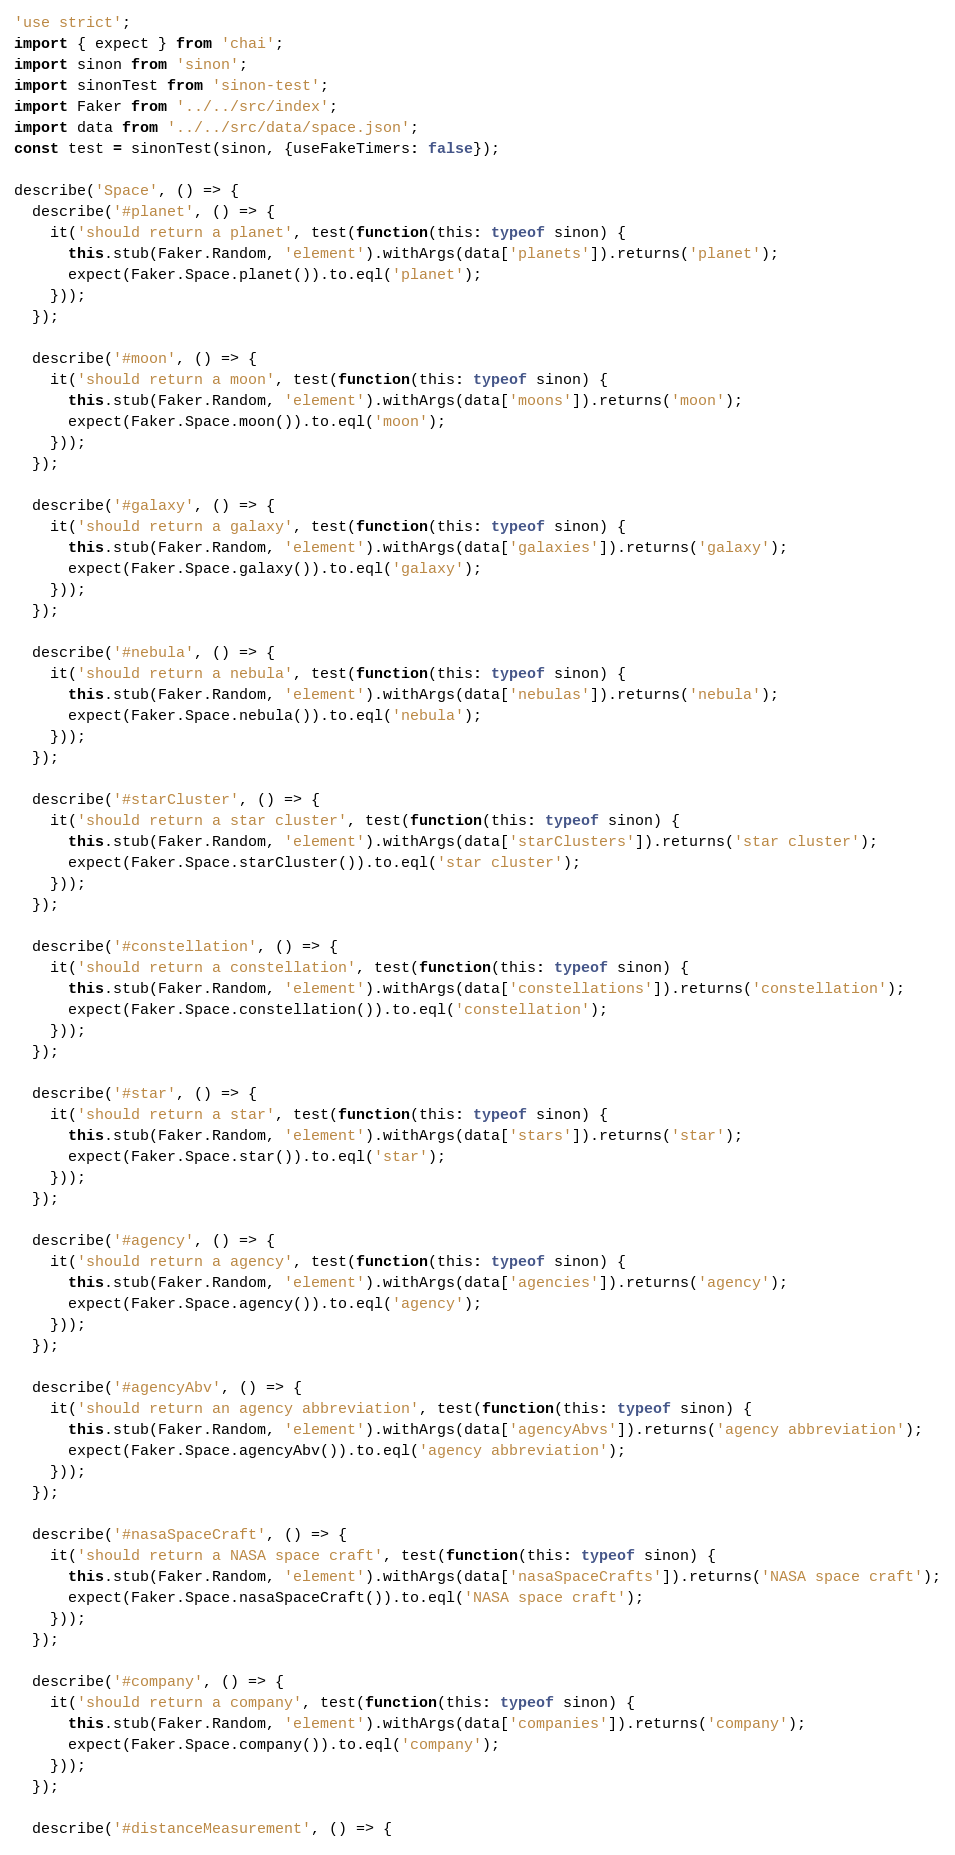<code> <loc_0><loc_0><loc_500><loc_500><_TypeScript_>'use strict';
import { expect } from 'chai';
import sinon from 'sinon';
import sinonTest from 'sinon-test';
import Faker from '../../src/index';
import data from '../../src/data/space.json';
const test = sinonTest(sinon, {useFakeTimers: false});

describe('Space', () => {
  describe('#planet', () => {
    it('should return a planet', test(function(this: typeof sinon) {
      this.stub(Faker.Random, 'element').withArgs(data['planets']).returns('planet');
      expect(Faker.Space.planet()).to.eql('planet');
    }));
  });

  describe('#moon', () => {
    it('should return a moon', test(function(this: typeof sinon) {
      this.stub(Faker.Random, 'element').withArgs(data['moons']).returns('moon');
      expect(Faker.Space.moon()).to.eql('moon');
    }));
  });

  describe('#galaxy', () => {
    it('should return a galaxy', test(function(this: typeof sinon) {
      this.stub(Faker.Random, 'element').withArgs(data['galaxies']).returns('galaxy');
      expect(Faker.Space.galaxy()).to.eql('galaxy');
    }));
  });

  describe('#nebula', () => {
    it('should return a nebula', test(function(this: typeof sinon) {
      this.stub(Faker.Random, 'element').withArgs(data['nebulas']).returns('nebula');
      expect(Faker.Space.nebula()).to.eql('nebula');
    }));
  });

  describe('#starCluster', () => {
    it('should return a star cluster', test(function(this: typeof sinon) {
      this.stub(Faker.Random, 'element').withArgs(data['starClusters']).returns('star cluster');
      expect(Faker.Space.starCluster()).to.eql('star cluster');
    }));
  });

  describe('#constellation', () => {
    it('should return a constellation', test(function(this: typeof sinon) {
      this.stub(Faker.Random, 'element').withArgs(data['constellations']).returns('constellation');
      expect(Faker.Space.constellation()).to.eql('constellation');
    }));
  });

  describe('#star', () => {
    it('should return a star', test(function(this: typeof sinon) {
      this.stub(Faker.Random, 'element').withArgs(data['stars']).returns('star');
      expect(Faker.Space.star()).to.eql('star');
    }));
  });

  describe('#agency', () => {
    it('should return a agency', test(function(this: typeof sinon) {
      this.stub(Faker.Random, 'element').withArgs(data['agencies']).returns('agency');
      expect(Faker.Space.agency()).to.eql('agency');
    }));
  });

  describe('#agencyAbv', () => {
    it('should return an agency abbreviation', test(function(this: typeof sinon) {
      this.stub(Faker.Random, 'element').withArgs(data['agencyAbvs']).returns('agency abbreviation');
      expect(Faker.Space.agencyAbv()).to.eql('agency abbreviation');
    }));
  });

  describe('#nasaSpaceCraft', () => {
    it('should return a NASA space craft', test(function(this: typeof sinon) {
      this.stub(Faker.Random, 'element').withArgs(data['nasaSpaceCrafts']).returns('NASA space craft');
      expect(Faker.Space.nasaSpaceCraft()).to.eql('NASA space craft');
    }));
  });

  describe('#company', () => {
    it('should return a company', test(function(this: typeof sinon) {
      this.stub(Faker.Random, 'element').withArgs(data['companies']).returns('company');
      expect(Faker.Space.company()).to.eql('company');
    }));
  });

  describe('#distanceMeasurement', () => {</code> 